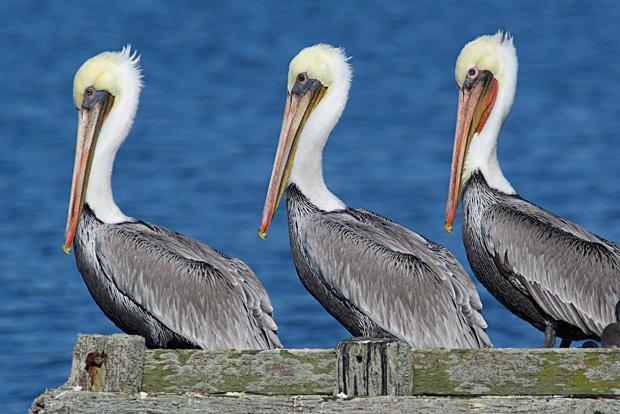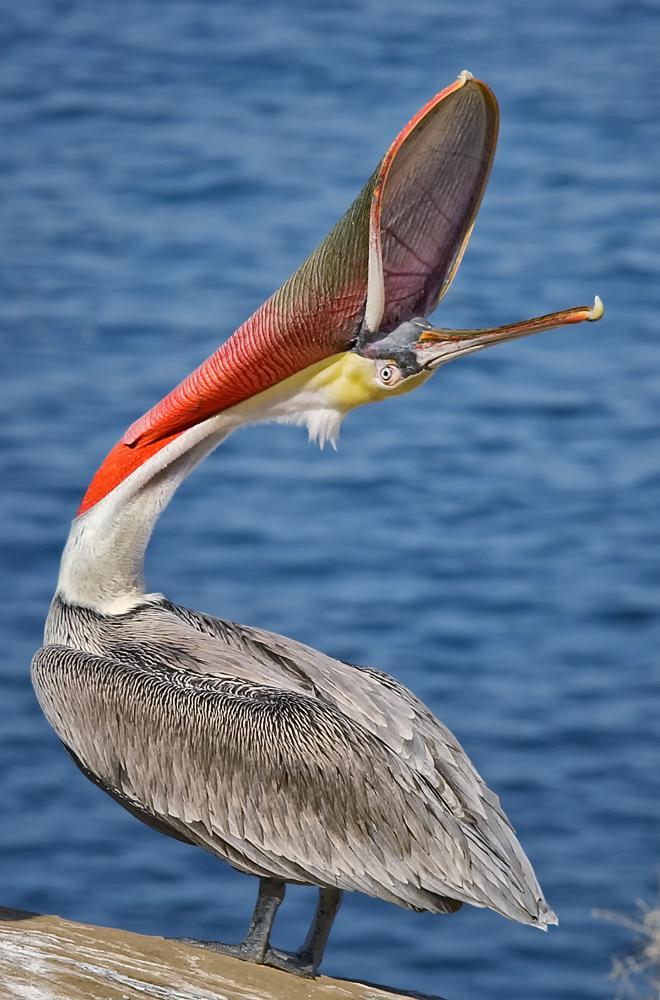The first image is the image on the left, the second image is the image on the right. Assess this claim about the two images: "Three birds are perched on flat planks of a deck.". Correct or not? Answer yes or no. No. The first image is the image on the left, the second image is the image on the right. Examine the images to the left and right. Is the description "Each image contains three left-facing pelicans posed in a row." accurate? Answer yes or no. No. 